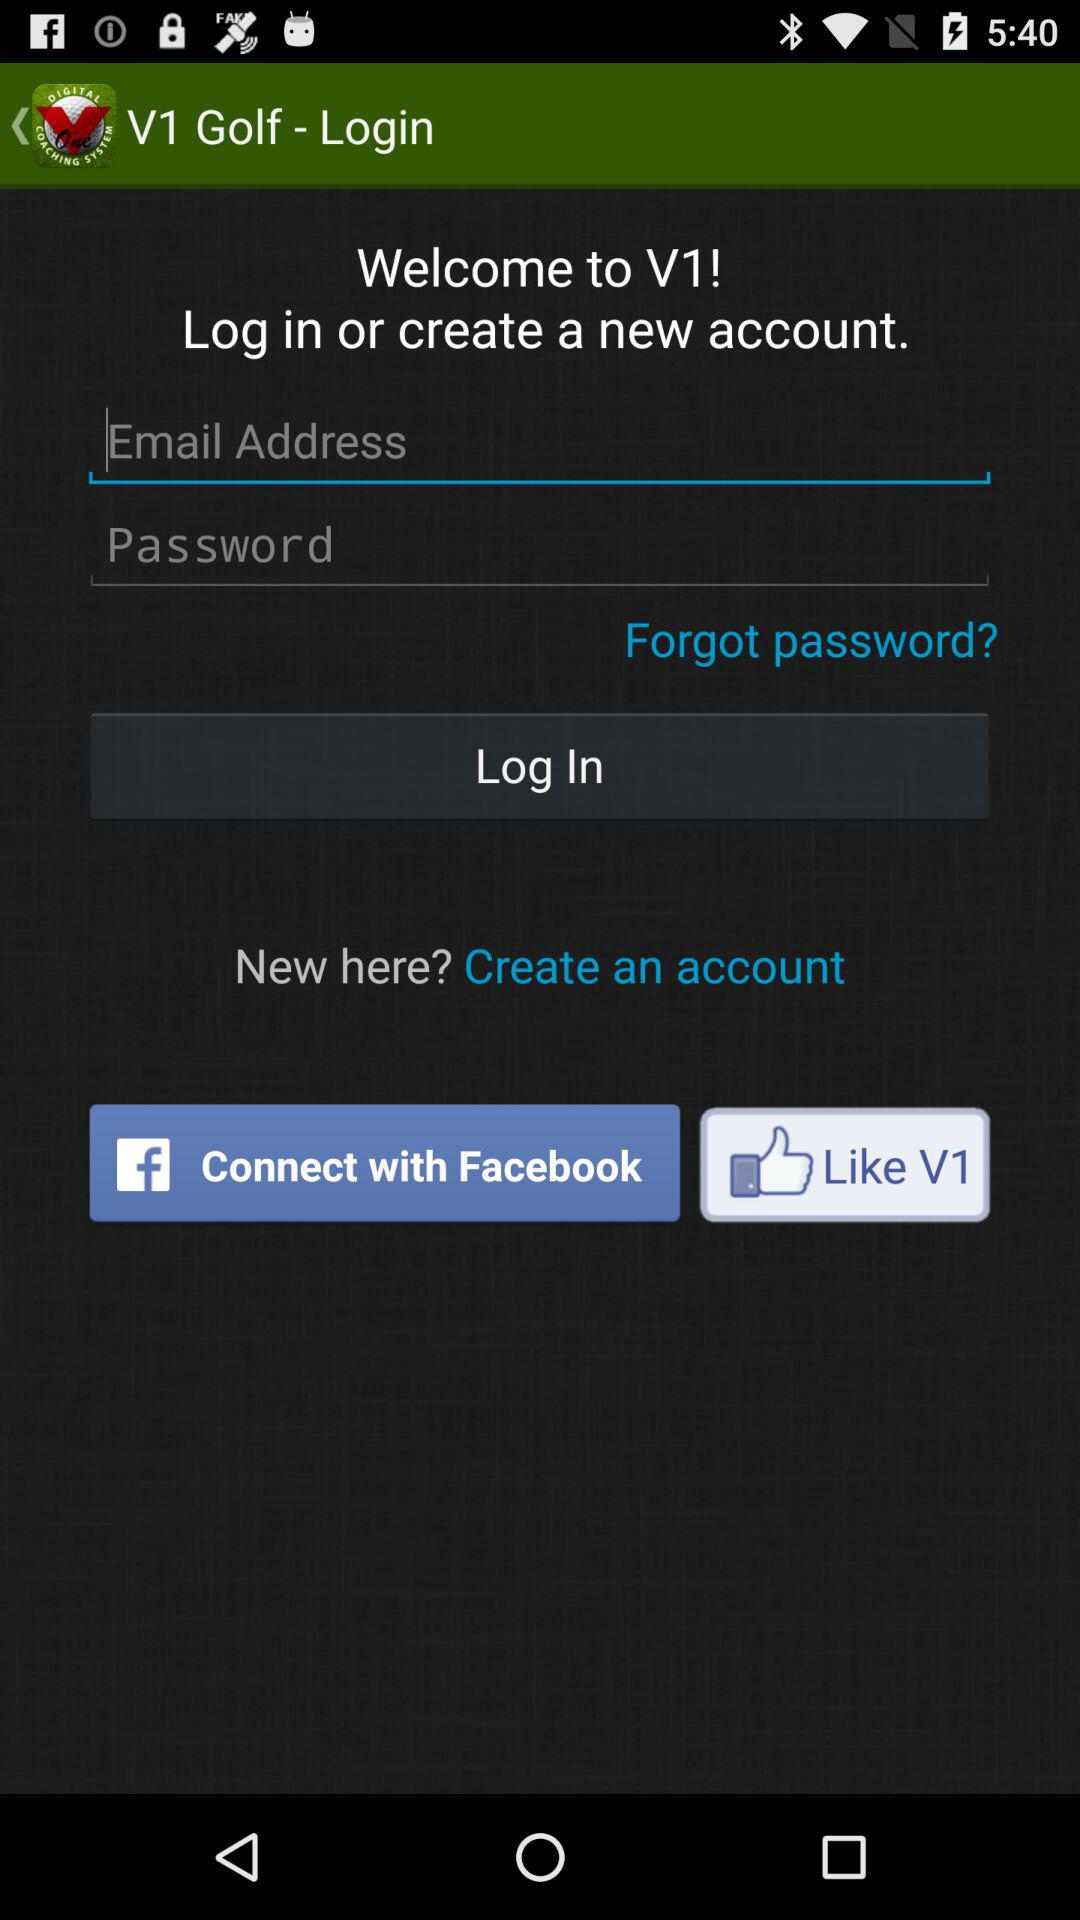What is the name of the application? The name of the application is "V1 Golf Premium Unlocker". 